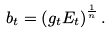<formula> <loc_0><loc_0><loc_500><loc_500>b _ { t } = \left ( g _ { t } E _ { t } \right ) ^ { \frac { 1 } { n } } .</formula> 